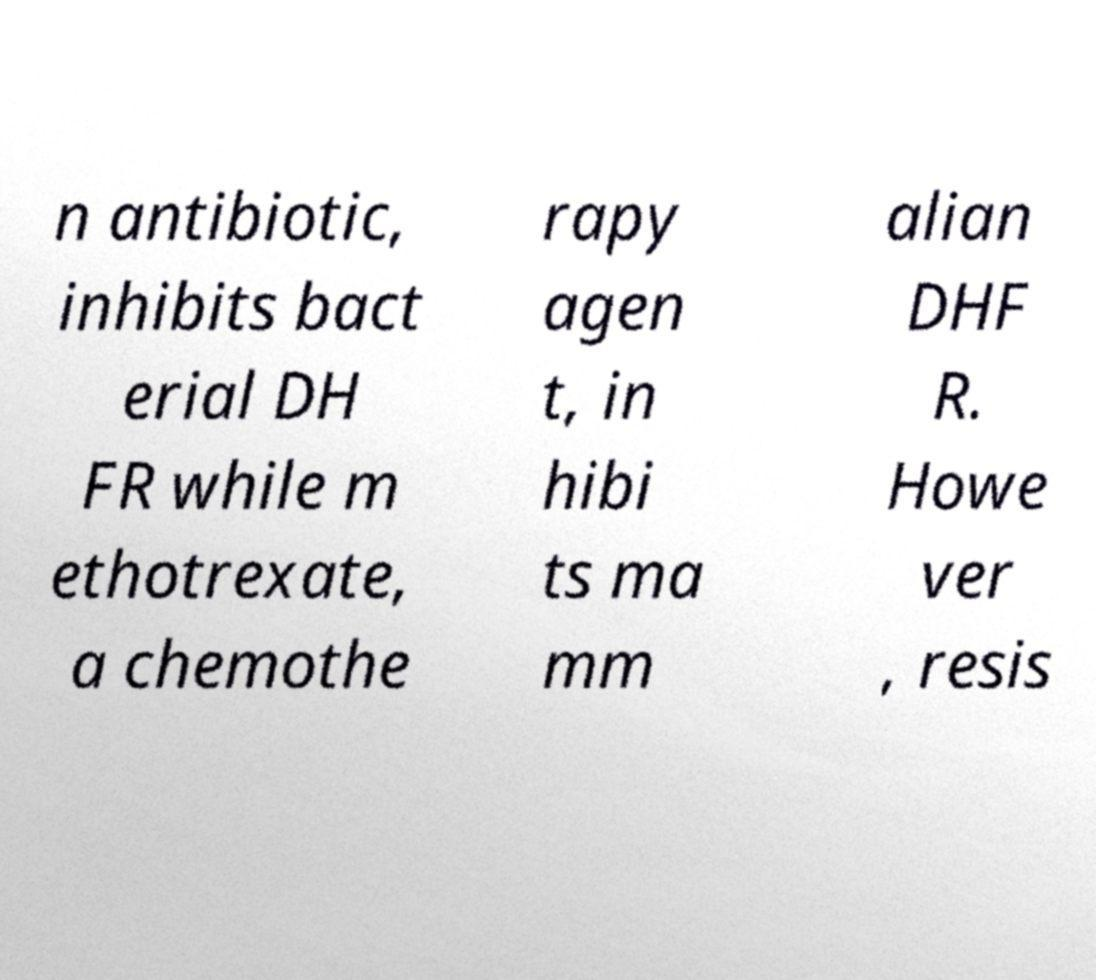For documentation purposes, I need the text within this image transcribed. Could you provide that? n antibiotic, inhibits bact erial DH FR while m ethotrexate, a chemothe rapy agen t, in hibi ts ma mm alian DHF R. Howe ver , resis 